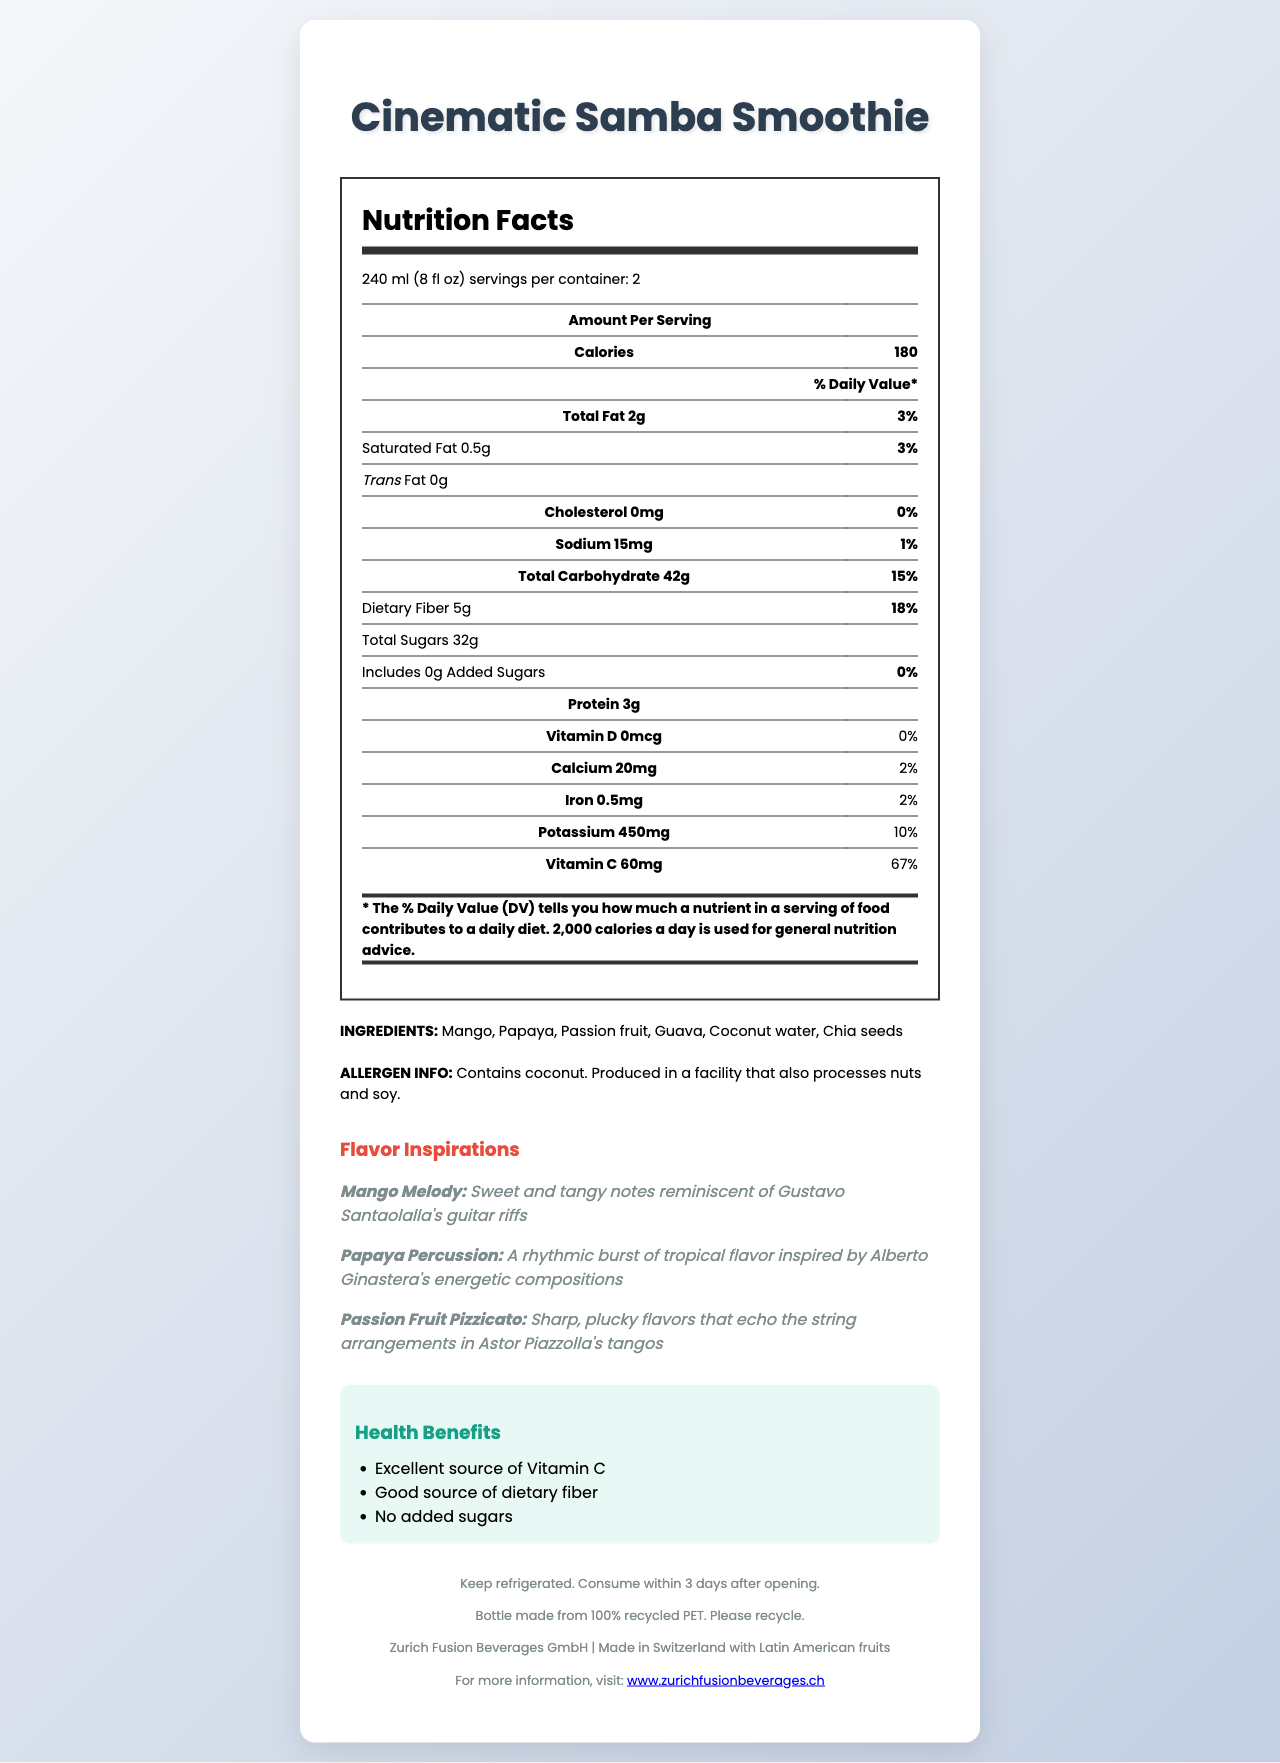what is the product name? The product name is displayed prominently at the top of the document.
Answer: Cinematic Samba Smoothie how many servings are in the container? Under the serving size information, it specifies "servings per container: 2."
Answer: 2 what is the total carbohydrate content per serving? The table lists "Total Carbohydrate: 42g" under the amount per serving section.
Answer: 42g which ingredient is mentioned as an allergen? The allergen information section states "Contains coconut."
Answer: Coconut how much dietary fiber does each serving provide? The nutrition facts table lists "Dietary Fiber: 5g" under the total carbohydrate section.
Answer: 5g what is the flavor description for "Mango Melody"? The flavor description section describes "Mango Melody" with this description.
Answer: Sweet and tangy notes reminiscent of Gustavo Santaolalla's guitar riffs how much vitamin C does a single serving contain and what's the daily value percentage? A. 30mg, 33% B. 45mg, 50% C. 60mg, 67% According to the nutrition facts, a serving contains "Vitamin C: 60mg" with a daily value of 67%.
Answer: C which of the following is NOT an ingredient in the smoothie? A. Chia seeds B. Mango C. Pineapple The listed ingredients are Mango, Papaya, Passion fruit, Guava, Coconut water, and Chia seeds; pineapple is not included.
Answer: C does the product contain any added sugars? The nutrition facts state "Includes 0g Added Sugars."
Answer: No does the product contain any iron? The nutrition facts table shows "Iron: 0.5mg" with a daily value of 2%.
Answer: Yes provide a brief summary of the nutritional benefits of the "Cinematic Samba Smoothie". The health claims section highlights these three key nutritional benefits prominently.
Answer: Excellent source of Vitamin C, good source of dietary fiber, no added sugars explain the storage instructions for the smoothie. The footer of the document contains these specific storage instructions for the product.
Answer: Keep refrigerated. Consume within 3 days after opening. which health claim is NOT mentioned on the label? A. Excellent source of Vitamin C B. Good source of dietary fiber C. Low in calories The health claims section states "Excellent source of Vitamin C", "Good source of dietary fiber", and "No added sugars"; "Low in calories" is not mentioned.
Answer: C what does the document say about recycling? The footer of the document provides this information regarding recycling.
Answer: Bottle made from 100% recycled PET. Please recycle. where are the fruits used to make this smoothie sourced from? The origin section states the smoothie is made in Switzerland with Latin American fruits.
Answer: Latin America 